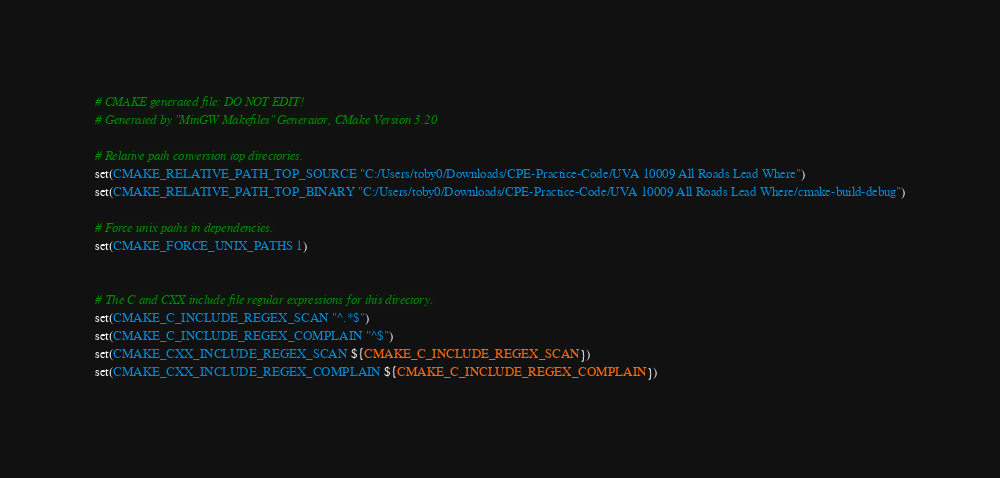<code> <loc_0><loc_0><loc_500><loc_500><_CMake_># CMAKE generated file: DO NOT EDIT!
# Generated by "MinGW Makefiles" Generator, CMake Version 3.20

# Relative path conversion top directories.
set(CMAKE_RELATIVE_PATH_TOP_SOURCE "C:/Users/toby0/Downloads/CPE-Practice-Code/UVA 10009 All Roads Lead Where")
set(CMAKE_RELATIVE_PATH_TOP_BINARY "C:/Users/toby0/Downloads/CPE-Practice-Code/UVA 10009 All Roads Lead Where/cmake-build-debug")

# Force unix paths in dependencies.
set(CMAKE_FORCE_UNIX_PATHS 1)


# The C and CXX include file regular expressions for this directory.
set(CMAKE_C_INCLUDE_REGEX_SCAN "^.*$")
set(CMAKE_C_INCLUDE_REGEX_COMPLAIN "^$")
set(CMAKE_CXX_INCLUDE_REGEX_SCAN ${CMAKE_C_INCLUDE_REGEX_SCAN})
set(CMAKE_CXX_INCLUDE_REGEX_COMPLAIN ${CMAKE_C_INCLUDE_REGEX_COMPLAIN})
</code> 